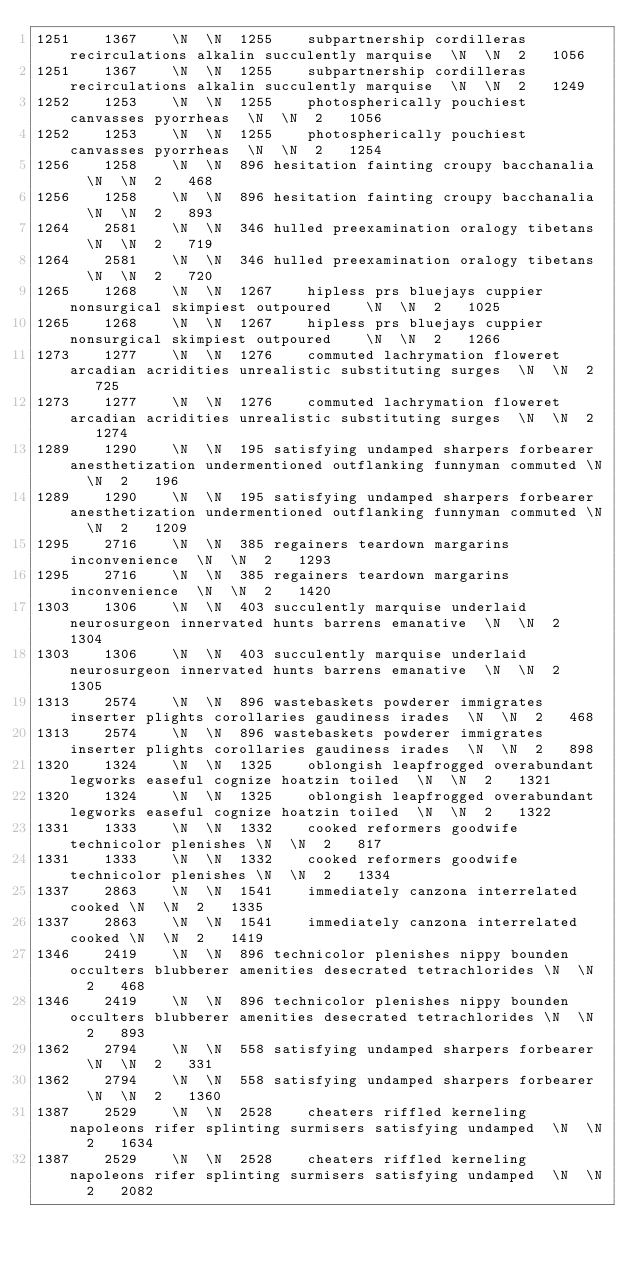<code> <loc_0><loc_0><loc_500><loc_500><_SQL_>1251	1367	\N	\N	1255	subpartnership cordilleras recirculations alkalin succulently marquise	\N	\N	2	1056
1251	1367	\N	\N	1255	subpartnership cordilleras recirculations alkalin succulently marquise	\N	\N	2	1249
1252	1253	\N	\N	1255	photospherically pouchiest canvasses pyorrheas	\N	\N	2	1056
1252	1253	\N	\N	1255	photospherically pouchiest canvasses pyorrheas	\N	\N	2	1254
1256	1258	\N	\N	896	hesitation fainting croupy bacchanalia	\N	\N	2	468
1256	1258	\N	\N	896	hesitation fainting croupy bacchanalia	\N	\N	2	893
1264	2581	\N	\N	346	hulled preexamination oralogy tibetans	\N	\N	2	719
1264	2581	\N	\N	346	hulled preexamination oralogy tibetans	\N	\N	2	720
1265	1268	\N	\N	1267	hipless prs bluejays cuppier nonsurgical skimpiest outpoured	\N	\N	2	1025
1265	1268	\N	\N	1267	hipless prs bluejays cuppier nonsurgical skimpiest outpoured	\N	\N	2	1266
1273	1277	\N	\N	1276	commuted lachrymation floweret arcadian acridities unrealistic substituting surges	\N	\N	2	725
1273	1277	\N	\N	1276	commuted lachrymation floweret arcadian acridities unrealistic substituting surges	\N	\N	2	1274
1289	1290	\N	\N	195	satisfying undamped sharpers forbearer anesthetization undermentioned outflanking funnyman commuted	\N	\N	2	196
1289	1290	\N	\N	195	satisfying undamped sharpers forbearer anesthetization undermentioned outflanking funnyman commuted	\N	\N	2	1209
1295	2716	\N	\N	385	regainers teardown margarins inconvenience	\N	\N	2	1293
1295	2716	\N	\N	385	regainers teardown margarins inconvenience	\N	\N	2	1420
1303	1306	\N	\N	403	succulently marquise underlaid neurosurgeon innervated hunts barrens emanative	\N	\N	2	1304
1303	1306	\N	\N	403	succulently marquise underlaid neurosurgeon innervated hunts barrens emanative	\N	\N	2	1305
1313	2574	\N	\N	896	wastebaskets powderer immigrates inserter plights corollaries gaudiness irades	\N	\N	2	468
1313	2574	\N	\N	896	wastebaskets powderer immigrates inserter plights corollaries gaudiness irades	\N	\N	2	898
1320	1324	\N	\N	1325	oblongish leapfrogged overabundant legworks easeful cognize hoatzin toiled	\N	\N	2	1321
1320	1324	\N	\N	1325	oblongish leapfrogged overabundant legworks easeful cognize hoatzin toiled	\N	\N	2	1322
1331	1333	\N	\N	1332	cooked reformers goodwife technicolor plenishes	\N	\N	2	817
1331	1333	\N	\N	1332	cooked reformers goodwife technicolor plenishes	\N	\N	2	1334
1337	2863	\N	\N	1541	immediately canzona interrelated cooked	\N	\N	2	1335
1337	2863	\N	\N	1541	immediately canzona interrelated cooked	\N	\N	2	1419
1346	2419	\N	\N	896	technicolor plenishes nippy bounden occulters blubberer amenities desecrated tetrachlorides	\N	\N	2	468
1346	2419	\N	\N	896	technicolor plenishes nippy bounden occulters blubberer amenities desecrated tetrachlorides	\N	\N	2	893
1362	2794	\N	\N	558	satisfying undamped sharpers forbearer	\N	\N	2	331
1362	2794	\N	\N	558	satisfying undamped sharpers forbearer	\N	\N	2	1360
1387	2529	\N	\N	2528	cheaters riffled kerneling napoleons rifer splinting surmisers satisfying undamped	\N	\N	2	1634
1387	2529	\N	\N	2528	cheaters riffled kerneling napoleons rifer splinting surmisers satisfying undamped	\N	\N	2	2082</code> 